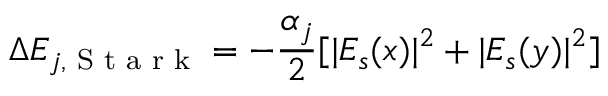Convert formula to latex. <formula><loc_0><loc_0><loc_500><loc_500>\Delta E _ { j , S t a r k } = - \frac { \alpha _ { j } } { 2 } [ | E _ { s } ( x ) | ^ { 2 } + | E _ { s } ( y ) | ^ { 2 } ]</formula> 